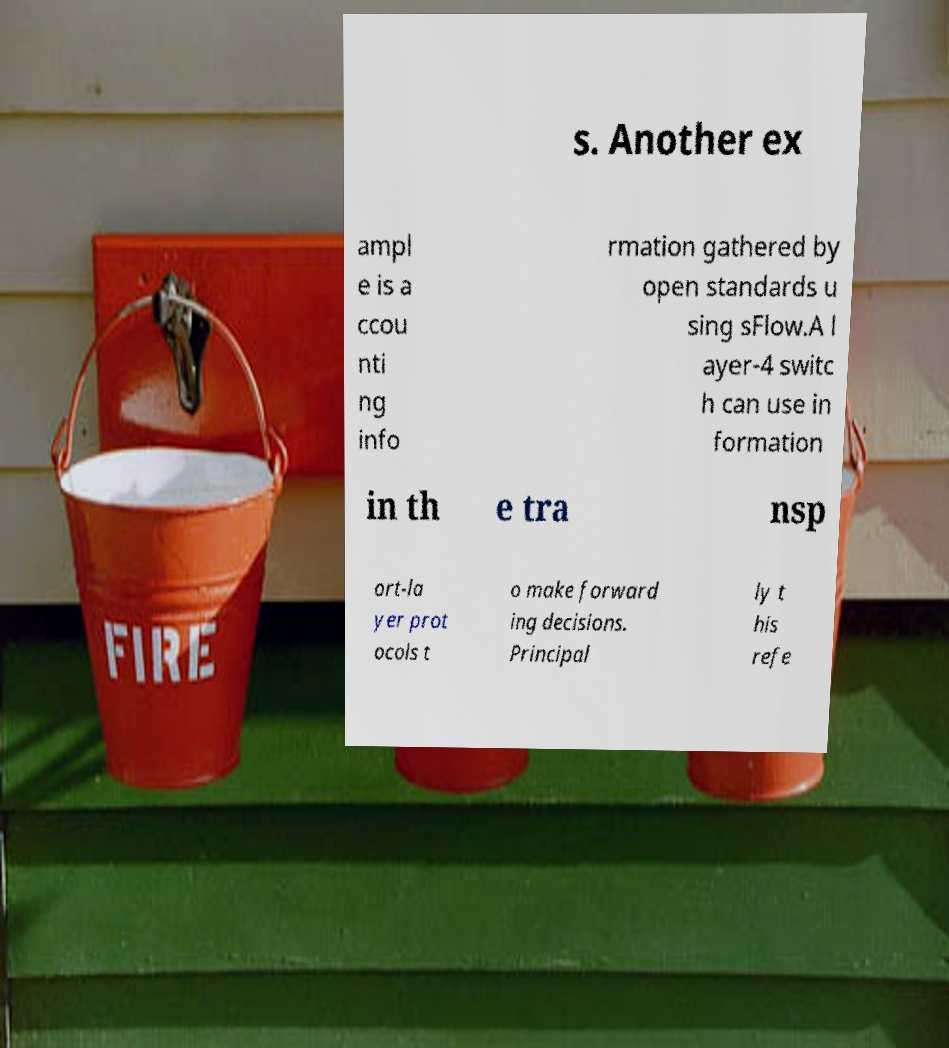Can you read and provide the text displayed in the image?This photo seems to have some interesting text. Can you extract and type it out for me? s. Another ex ampl e is a ccou nti ng info rmation gathered by open standards u sing sFlow.A l ayer-4 switc h can use in formation in th e tra nsp ort-la yer prot ocols t o make forward ing decisions. Principal ly t his refe 